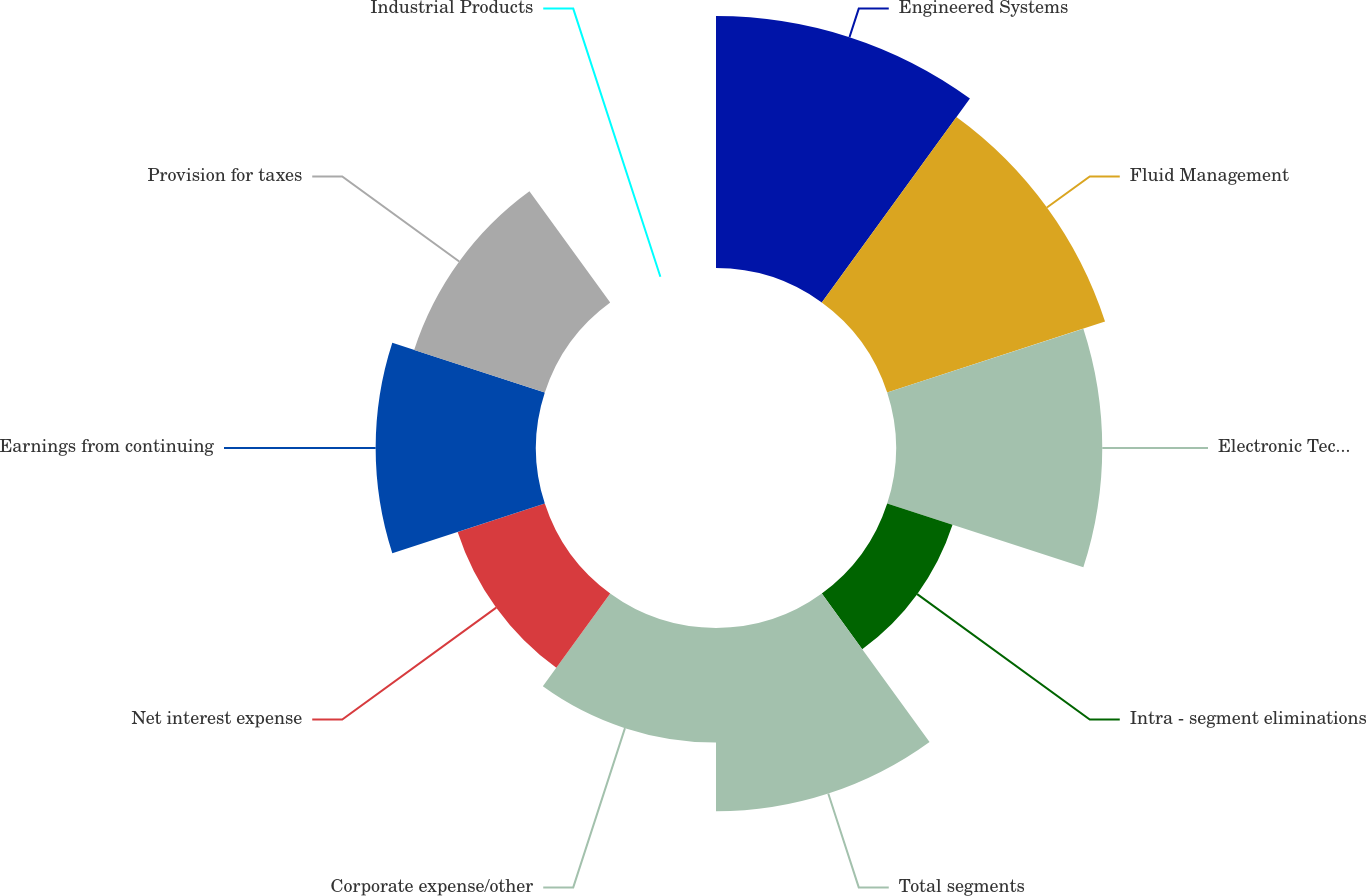<chart> <loc_0><loc_0><loc_500><loc_500><pie_chart><fcel>Engineered Systems<fcel>Fluid Management<fcel>Electronic Technologies<fcel>Intra - segment eliminations<fcel>Total segments<fcel>Corporate expense/other<fcel>Net interest expense<fcel>Earnings from continuing<fcel>Provision for taxes<fcel>Industrial Products<nl><fcel>17.46%<fcel>15.87%<fcel>14.29%<fcel>4.76%<fcel>12.7%<fcel>7.94%<fcel>6.35%<fcel>11.11%<fcel>9.52%<fcel>0.0%<nl></chart> 